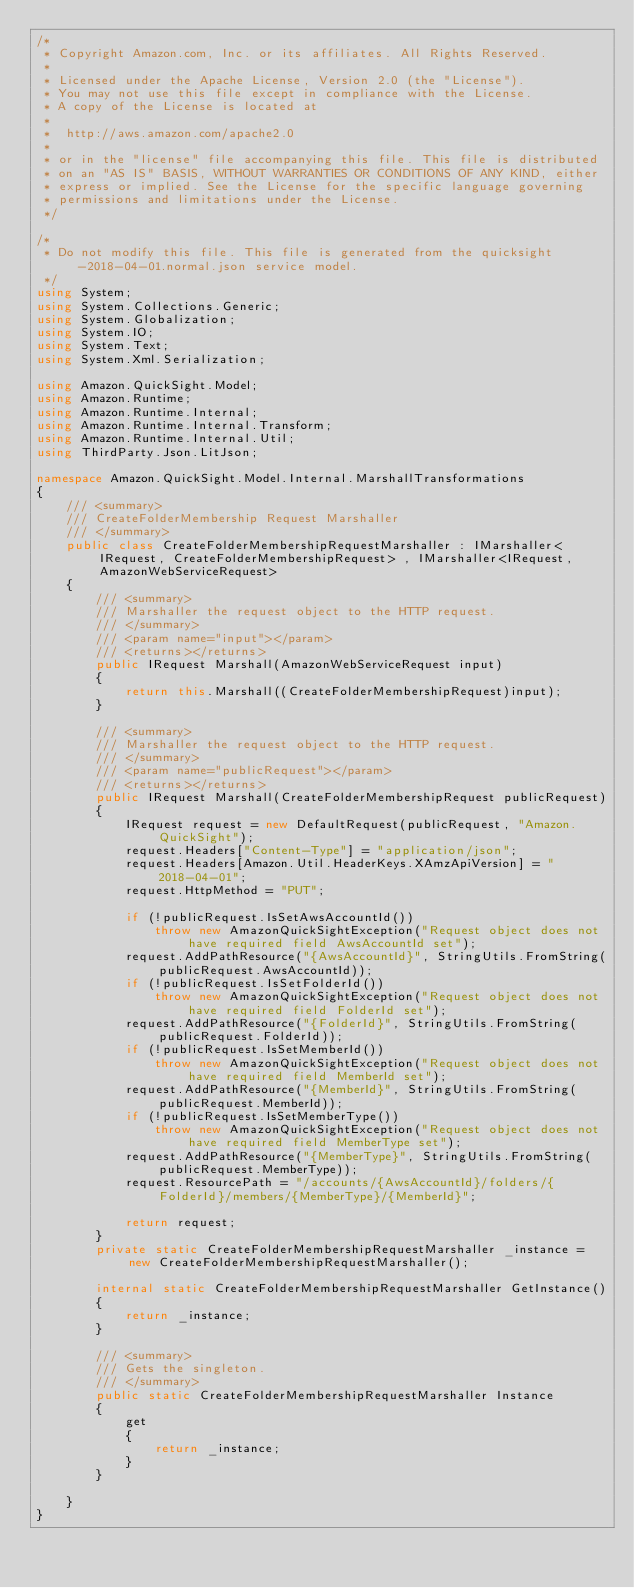Convert code to text. <code><loc_0><loc_0><loc_500><loc_500><_C#_>/*
 * Copyright Amazon.com, Inc. or its affiliates. All Rights Reserved.
 * 
 * Licensed under the Apache License, Version 2.0 (the "License").
 * You may not use this file except in compliance with the License.
 * A copy of the License is located at
 * 
 *  http://aws.amazon.com/apache2.0
 * 
 * or in the "license" file accompanying this file. This file is distributed
 * on an "AS IS" BASIS, WITHOUT WARRANTIES OR CONDITIONS OF ANY KIND, either
 * express or implied. See the License for the specific language governing
 * permissions and limitations under the License.
 */

/*
 * Do not modify this file. This file is generated from the quicksight-2018-04-01.normal.json service model.
 */
using System;
using System.Collections.Generic;
using System.Globalization;
using System.IO;
using System.Text;
using System.Xml.Serialization;

using Amazon.QuickSight.Model;
using Amazon.Runtime;
using Amazon.Runtime.Internal;
using Amazon.Runtime.Internal.Transform;
using Amazon.Runtime.Internal.Util;
using ThirdParty.Json.LitJson;

namespace Amazon.QuickSight.Model.Internal.MarshallTransformations
{
    /// <summary>
    /// CreateFolderMembership Request Marshaller
    /// </summary>       
    public class CreateFolderMembershipRequestMarshaller : IMarshaller<IRequest, CreateFolderMembershipRequest> , IMarshaller<IRequest,AmazonWebServiceRequest>
    {
        /// <summary>
        /// Marshaller the request object to the HTTP request.
        /// </summary>  
        /// <param name="input"></param>
        /// <returns></returns>
        public IRequest Marshall(AmazonWebServiceRequest input)
        {
            return this.Marshall((CreateFolderMembershipRequest)input);
        }

        /// <summary>
        /// Marshaller the request object to the HTTP request.
        /// </summary>  
        /// <param name="publicRequest"></param>
        /// <returns></returns>
        public IRequest Marshall(CreateFolderMembershipRequest publicRequest)
        {
            IRequest request = new DefaultRequest(publicRequest, "Amazon.QuickSight");
            request.Headers["Content-Type"] = "application/json";
            request.Headers[Amazon.Util.HeaderKeys.XAmzApiVersion] = "2018-04-01";
            request.HttpMethod = "PUT";

            if (!publicRequest.IsSetAwsAccountId())
                throw new AmazonQuickSightException("Request object does not have required field AwsAccountId set");
            request.AddPathResource("{AwsAccountId}", StringUtils.FromString(publicRequest.AwsAccountId));
            if (!publicRequest.IsSetFolderId())
                throw new AmazonQuickSightException("Request object does not have required field FolderId set");
            request.AddPathResource("{FolderId}", StringUtils.FromString(publicRequest.FolderId));
            if (!publicRequest.IsSetMemberId())
                throw new AmazonQuickSightException("Request object does not have required field MemberId set");
            request.AddPathResource("{MemberId}", StringUtils.FromString(publicRequest.MemberId));
            if (!publicRequest.IsSetMemberType())
                throw new AmazonQuickSightException("Request object does not have required field MemberType set");
            request.AddPathResource("{MemberType}", StringUtils.FromString(publicRequest.MemberType));
            request.ResourcePath = "/accounts/{AwsAccountId}/folders/{FolderId}/members/{MemberType}/{MemberId}";

            return request;
        }
        private static CreateFolderMembershipRequestMarshaller _instance = new CreateFolderMembershipRequestMarshaller();        

        internal static CreateFolderMembershipRequestMarshaller GetInstance()
        {
            return _instance;
        }

        /// <summary>
        /// Gets the singleton.
        /// </summary>  
        public static CreateFolderMembershipRequestMarshaller Instance
        {
            get
            {
                return _instance;
            }
        }

    }
}</code> 